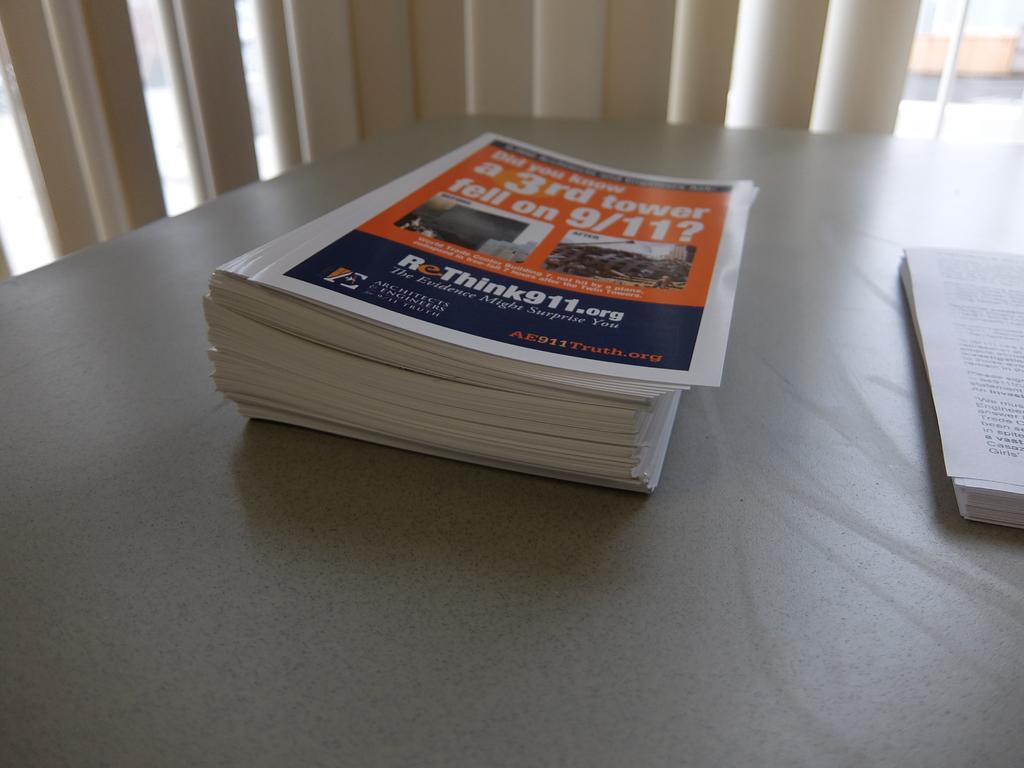What is the url on the paper?
Ensure brevity in your answer.  Rethink911.org. Is this about a 3rd tower falling on 9/11?
Give a very brief answer. Yes. 